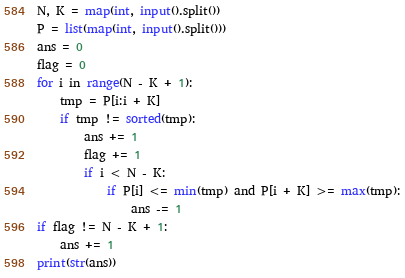Convert code to text. <code><loc_0><loc_0><loc_500><loc_500><_Python_>N, K = map(int, input().split())
P = list(map(int, input().split()))
ans = 0
flag = 0
for i in range(N - K + 1):
    tmp = P[i:i + K]
    if tmp != sorted(tmp):
        ans += 1
        flag += 1
        if i < N - K:
            if P[i] <= min(tmp) and P[i + K] >= max(tmp):
                ans -= 1
if flag != N - K + 1:
    ans += 1
print(str(ans))
</code> 